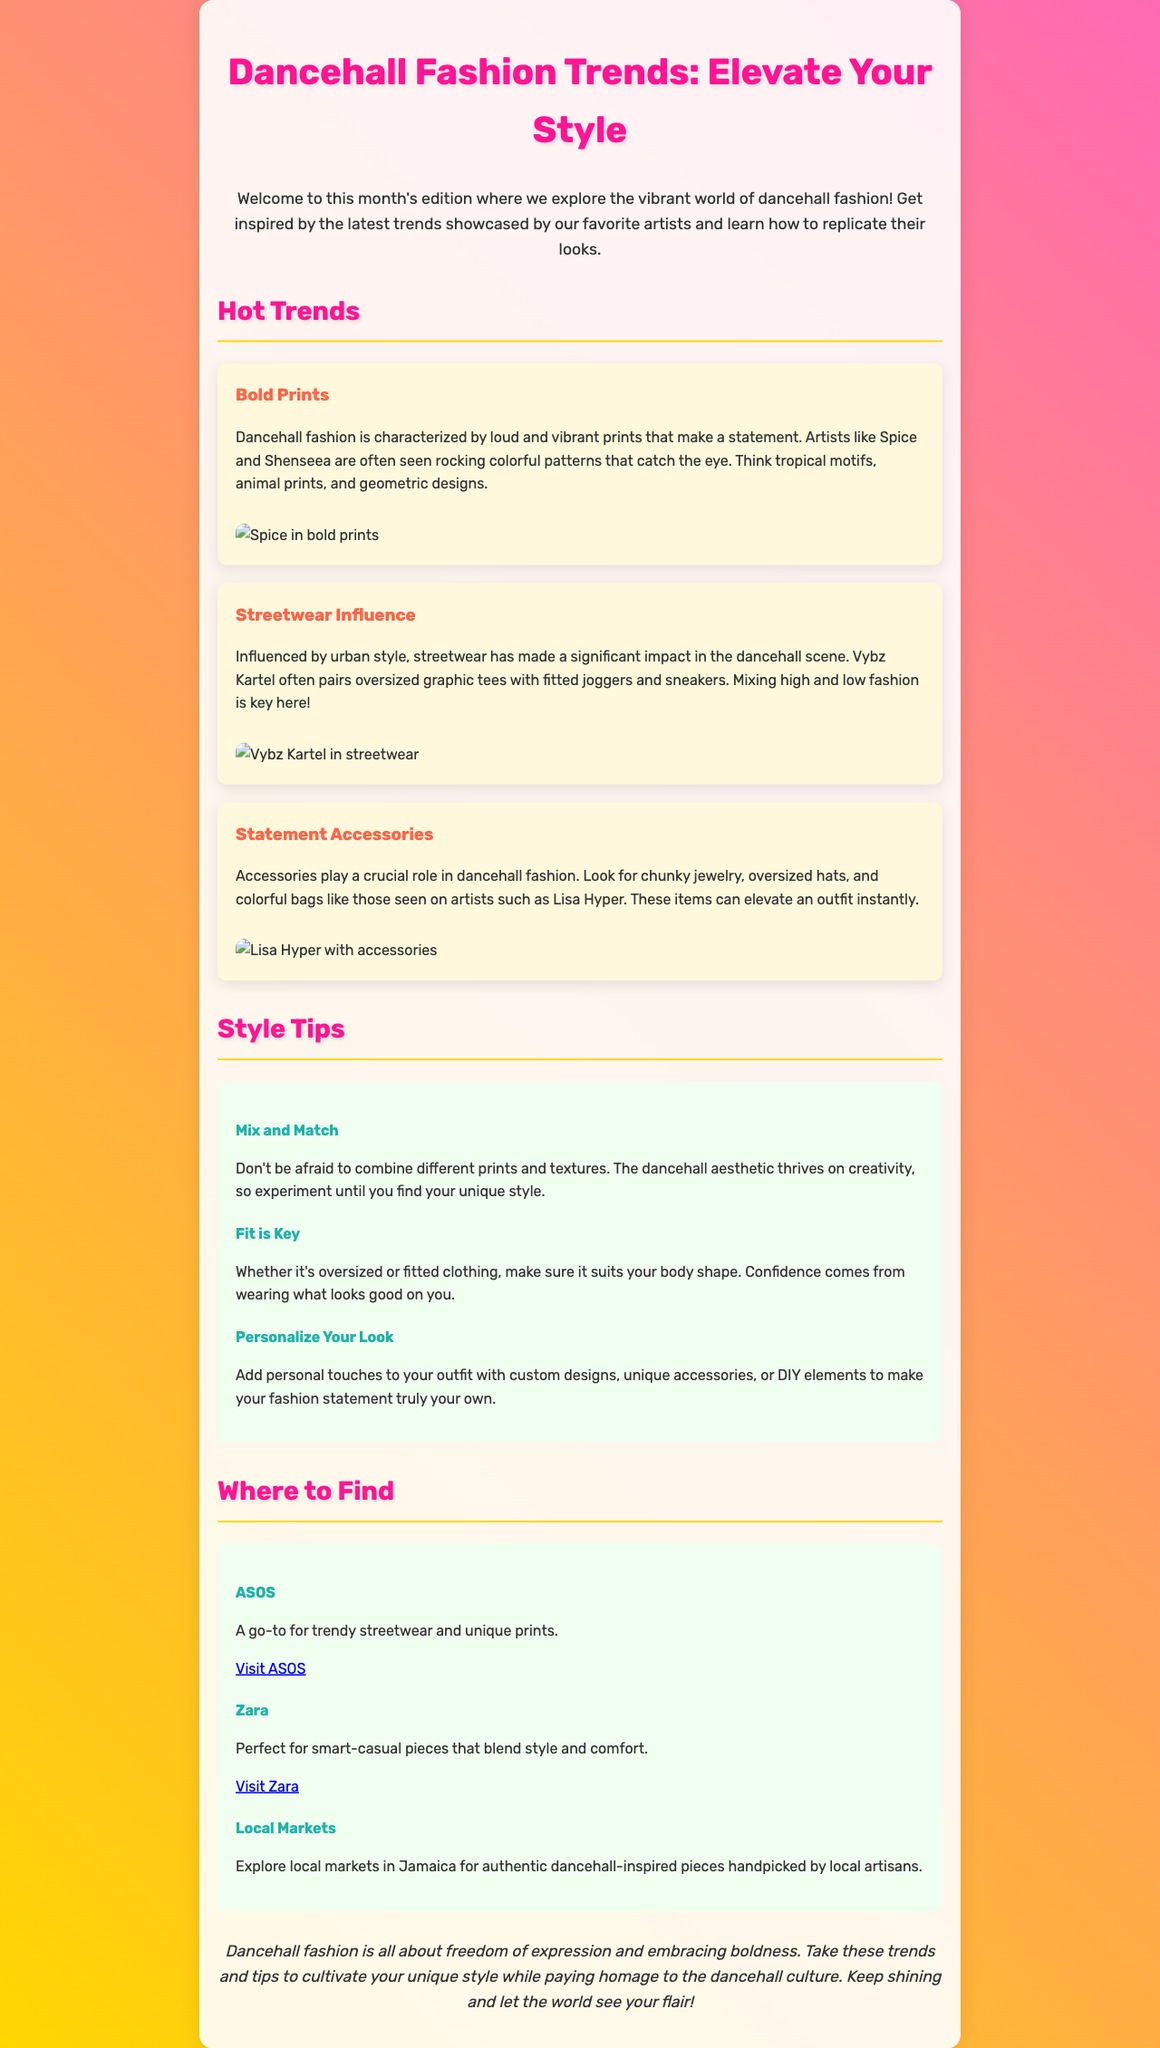What are the key fashion elements in dancehall? The document highlights bold prints, streetwear influence, and statement accessories as key fashion elements in the dancehall scene.
Answer: Bold prints, streetwear influence, statement accessories Who are two artists mentioned for showcasing bold prints? The document mentions Spice and Shenseea as artists known for their vibrant prints.
Answer: Spice, Shenseea What type of clothing is Vybz Kartel known for in dancehall fashion? Vybz Kartel is known for pairing oversized graphic tees with fitted joggers and sneakers.
Answer: Oversized graphic tees, fitted joggers, sneakers Which store is suggested for trendy streetwear? The document lists ASOS as a go-to store for trendy streetwear and unique prints.
Answer: ASOS What is one style tip mentioned for dancehall fashion? The document suggests mixing and matching different prints and textures as a style tip in dancehall fashion.
Answer: Mix and match What is emphasized as essential when choosing clothing? The document emphasizes that the fit of clothing is crucial to look good and feel confident.
Answer: Fit is key Where can you find authentic dancehall-inspired pieces? The document mentions local markets in Jamaica for authentic dancehall-inspired pieces.
Answer: Local markets What color is used for headings in the newsletter? The document specifies that the color for headings is a shade of pink.
Answer: Pink What is the concluding message of the newsletter? The conclusion of the newsletter emphasizes the importance of freedom of expression and embracing boldness in fashion.
Answer: Freedom of expression and embracing boldness 